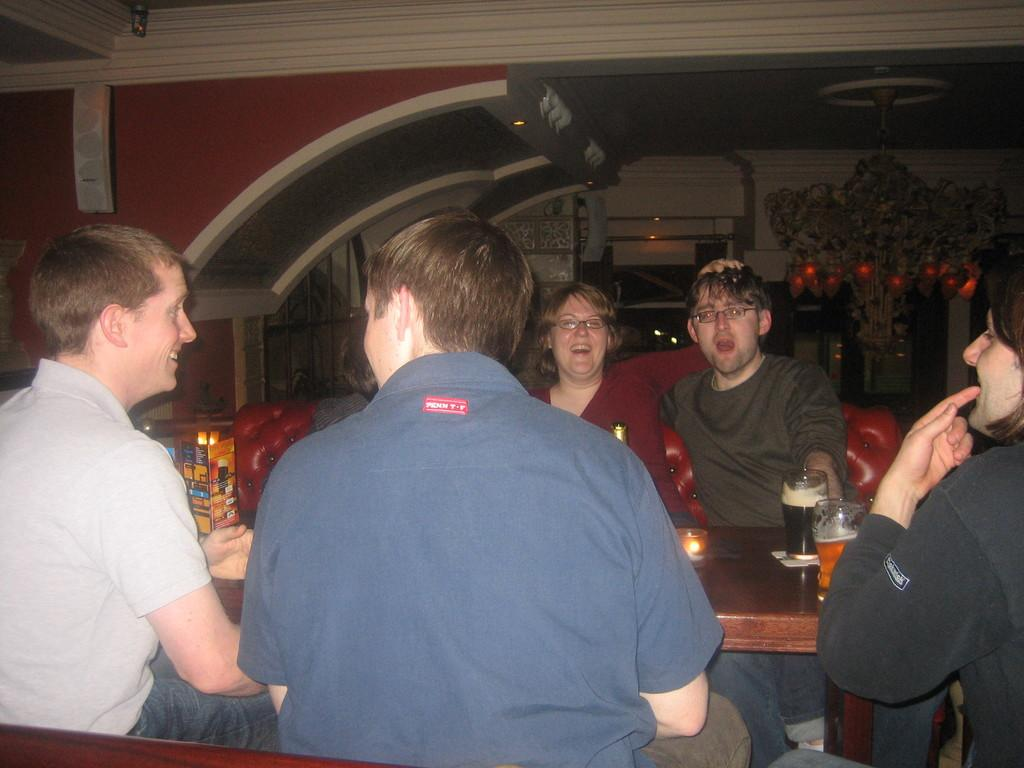What are the people in the image doing? The people in the image are sitting in front of a table. What objects can be seen on the table? There are glasses on the table. Can you describe any other objects in the image? Yes, there is a lamp in the image. Where is the lamp located in relation to the roof? The lamp is near the roof. What type of train can be seen passing by in the image? There is no train present in the image. Is the father of the people in the image also sitting at the table? The provided facts do not mention the presence of a father, so we cannot determine if he is sitting at the table or not. 